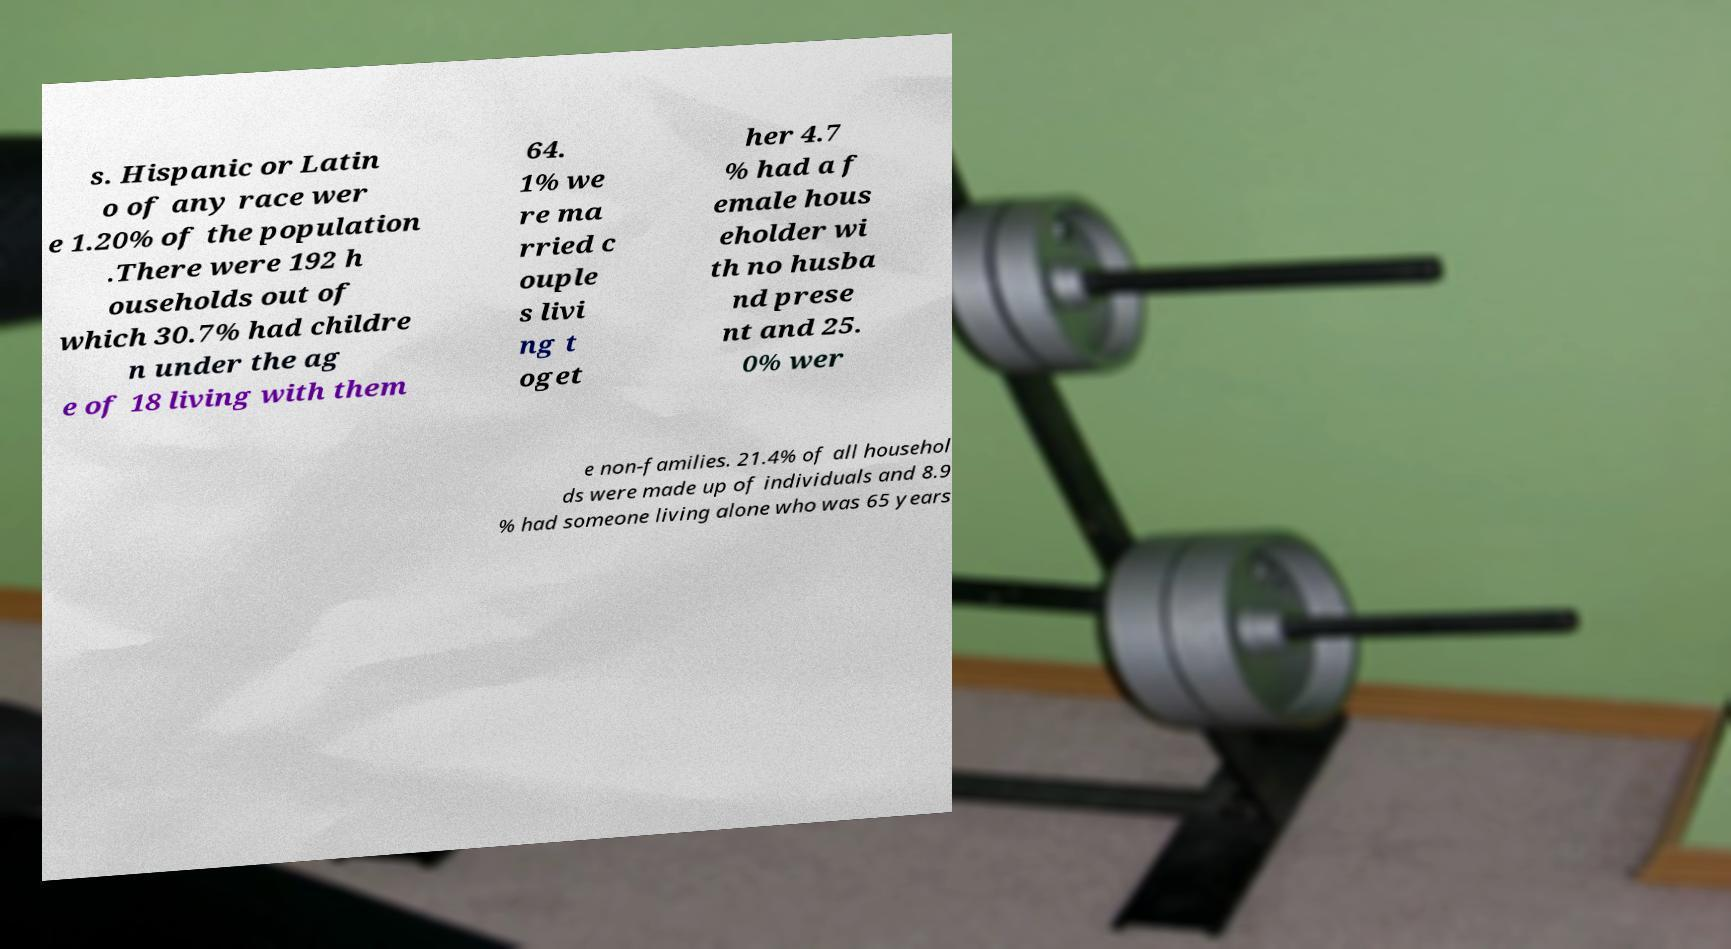Can you read and provide the text displayed in the image?This photo seems to have some interesting text. Can you extract and type it out for me? s. Hispanic or Latin o of any race wer e 1.20% of the population .There were 192 h ouseholds out of which 30.7% had childre n under the ag e of 18 living with them 64. 1% we re ma rried c ouple s livi ng t oget her 4.7 % had a f emale hous eholder wi th no husba nd prese nt and 25. 0% wer e non-families. 21.4% of all househol ds were made up of individuals and 8.9 % had someone living alone who was 65 years 